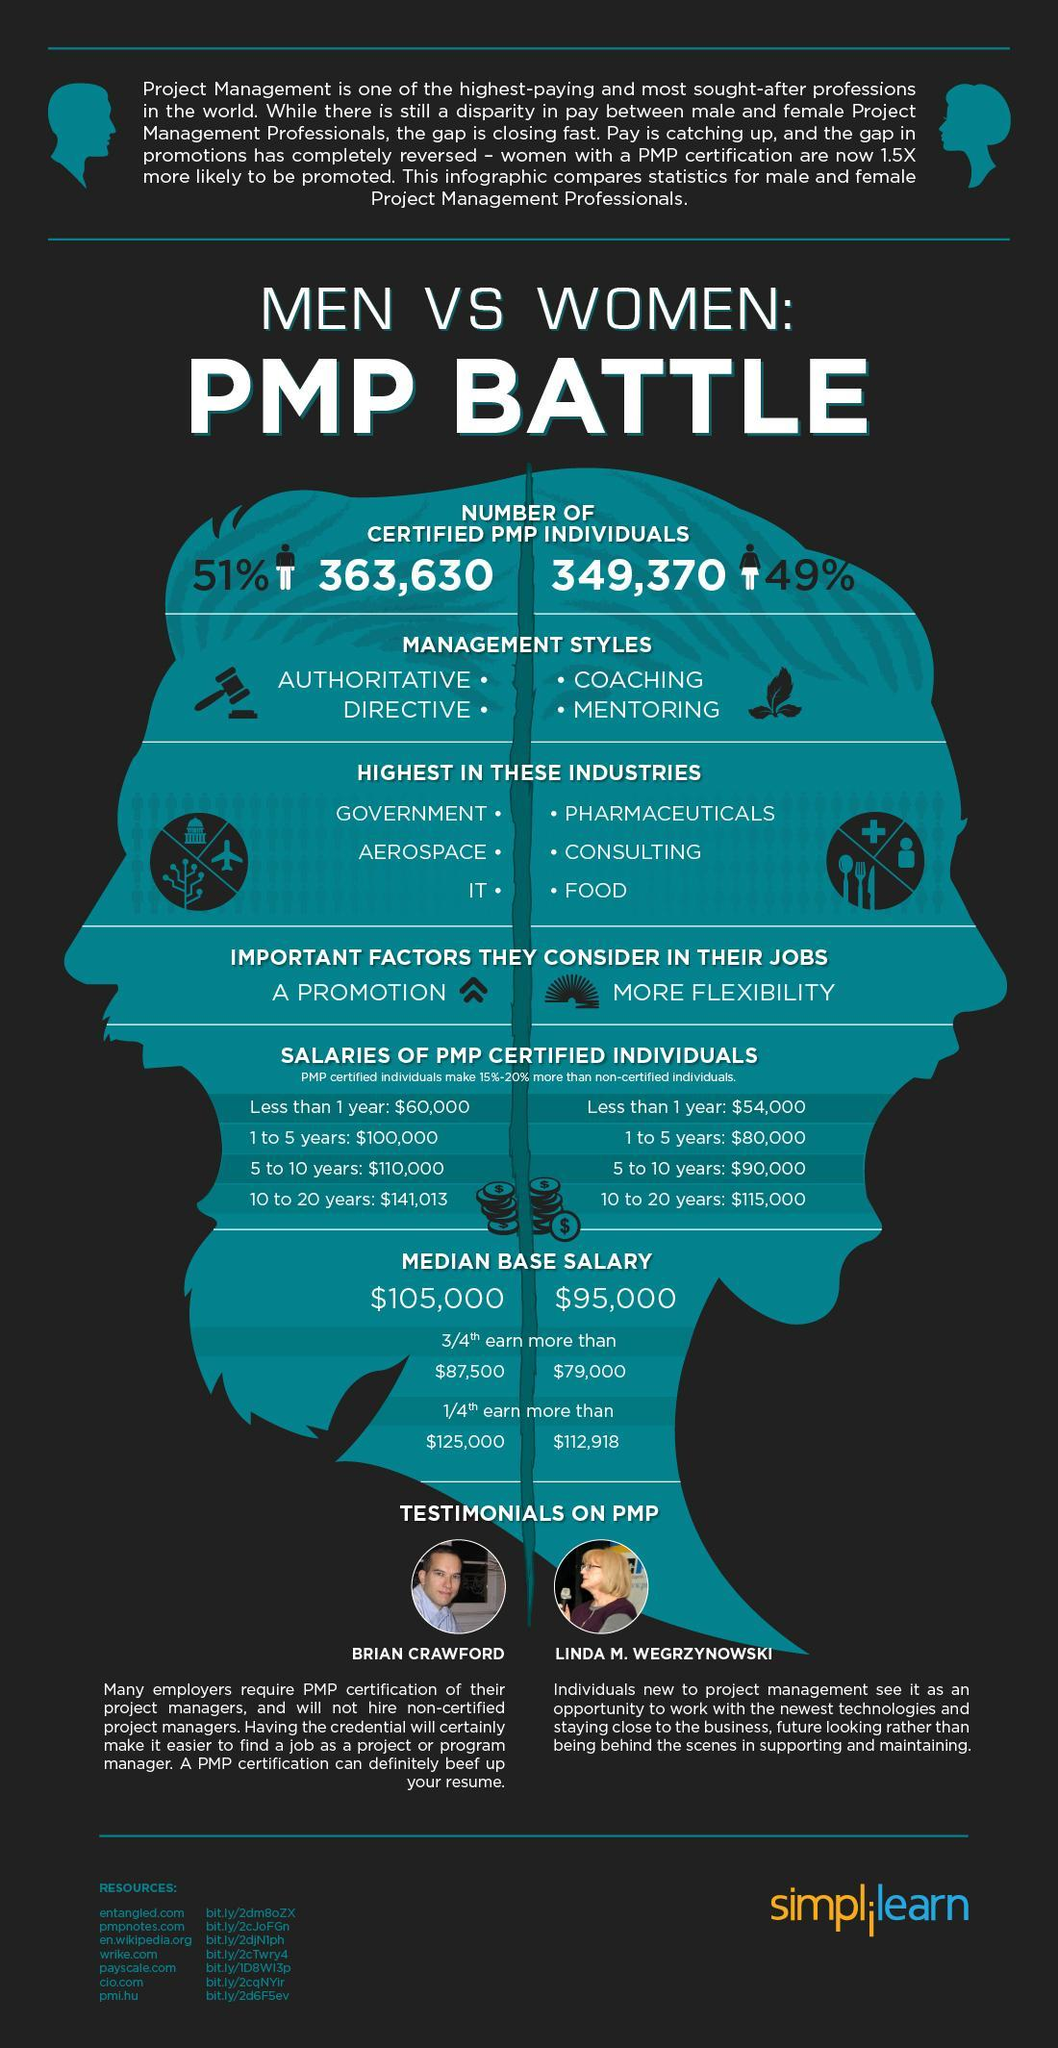What is the number of PMP certified women, 363,630, or 349,370?
Answer the question with a short phrase. 349,370 Which industries have the highest PMP certified women, Government, Pharmaceuticals, Aerospace, IT, or Consulting? Pharmaceuticals, Consulting Which category of experience has the biggest gap in between PMP certified and non-certified professionals? 10 to 20 years What is the management style of PMP certified men, Authoritative, Coaching, Directive, or Mentoring? Authoritative, Directive 